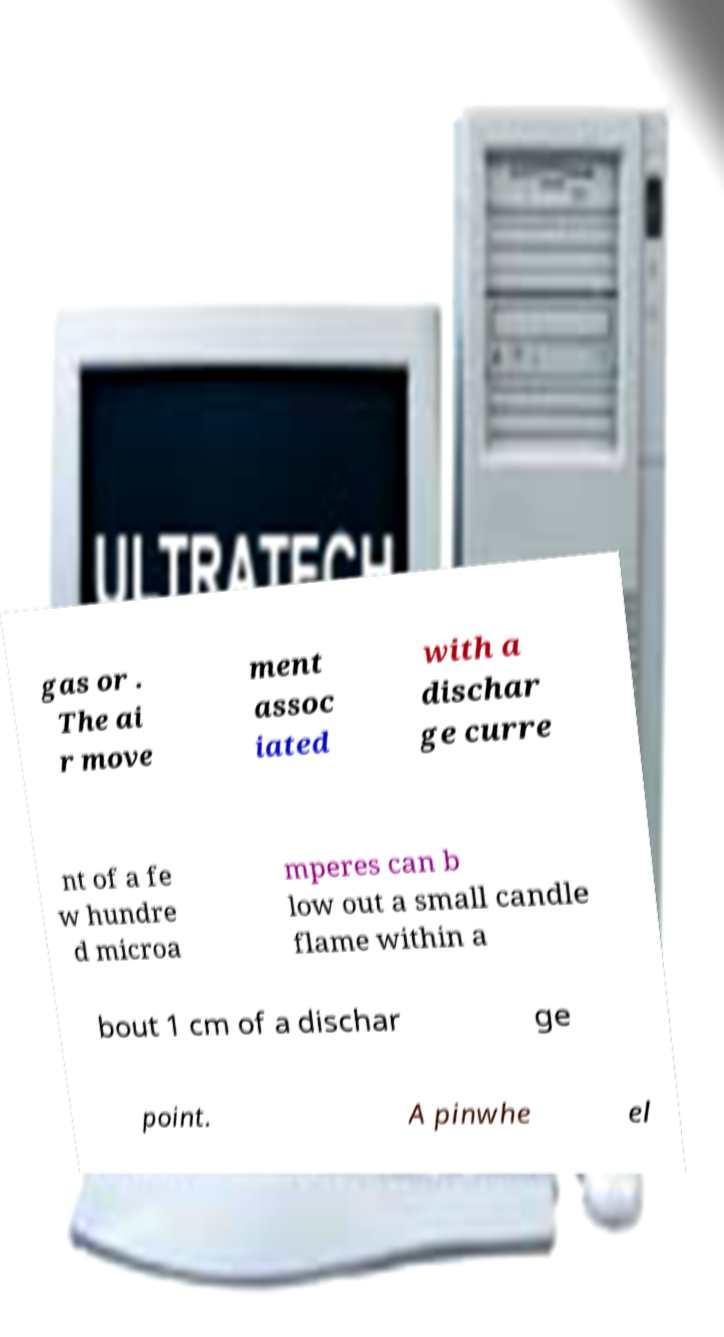Please read and relay the text visible in this image. What does it say? gas or . The ai r move ment assoc iated with a dischar ge curre nt of a fe w hundre d microa mperes can b low out a small candle flame within a bout 1 cm of a dischar ge point. A pinwhe el 